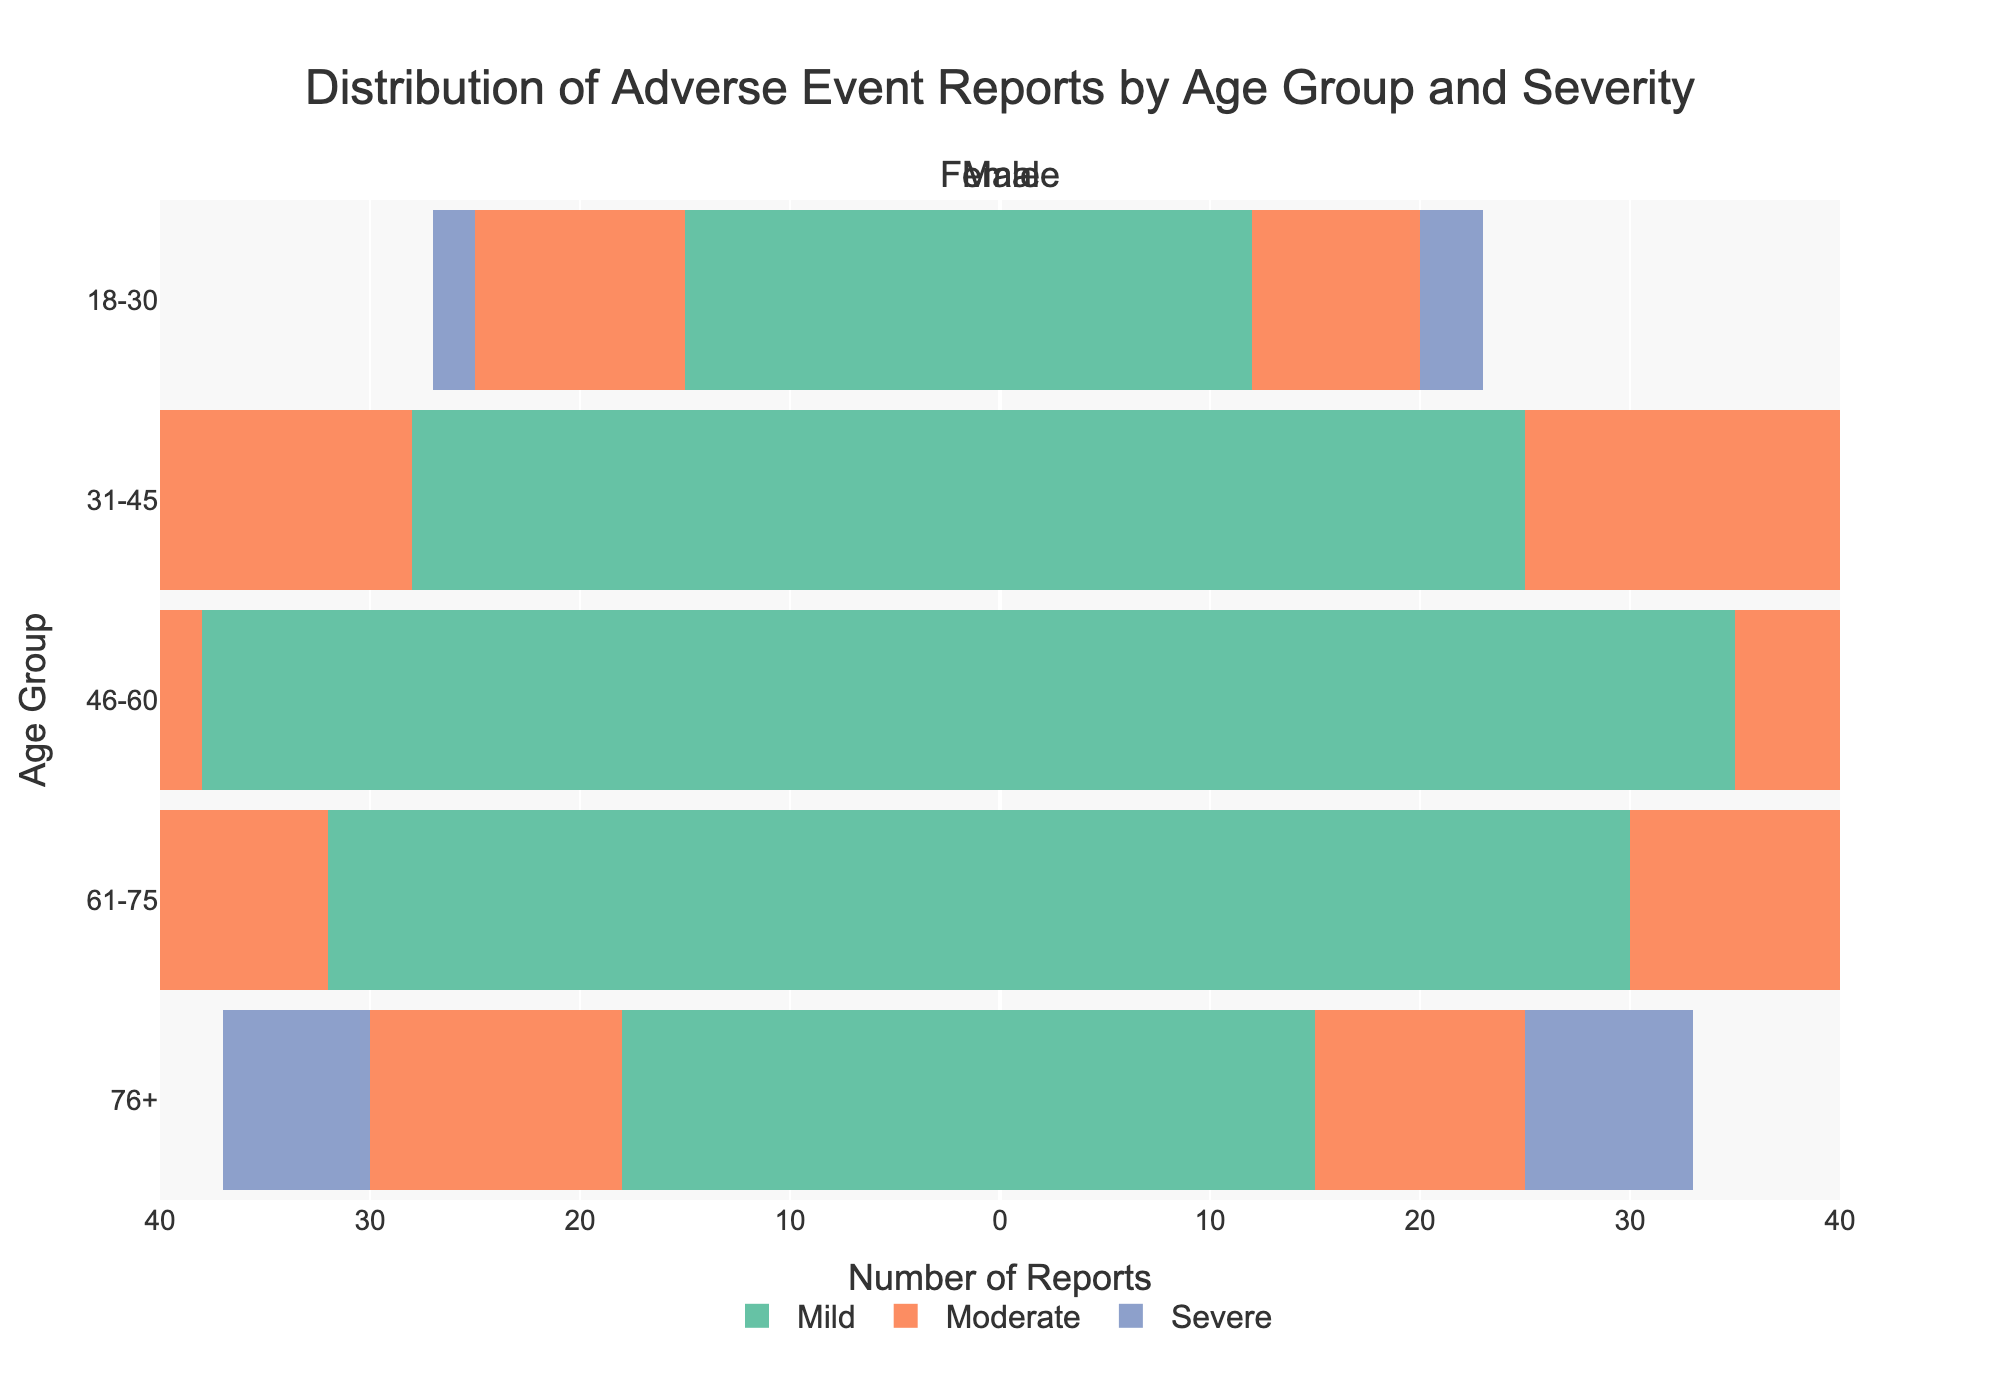Which age group has the highest number of mild adverse event reports in males? Look at the mild category for males and identify the age group with the longest bar. The age group 46-60 has a bar extending to 35, which is the highest.
Answer: 46-60 In the 31-45 age group, how many total severe adverse event reports were there? Add the severe adverse event reports for both males and females in the 31-45 age group. For males, there are 7 reports, and for females, there are 6 reports. Summing these gives 7 + 6 = 13.
Answer: 13 Which severity level has the most adverse event reports in females aged 76+? Look at the bars for females in the 76+ age group and identify which severity level's bar extends the furthest to the left. The mild severity has a bar extending to -18.
Answer: Mild Compare the number of moderate adverse event reports in males between the 46-60 age group and the 61-75 age group. Which age group has more reports? Locate the bars for moderate severity in males for the age groups 46-60 and 61-75. For 46-60, the bar extends to 22. For 61-75, it extends to 20, showing 46-60 has more reports.
Answer: 46-60 What is the total number of adverse event reports for both males and females in the 18-30 age group? Sum the adverse event reports for males and females in all severity levels for the 18-30 age group. (12+8+3) + (15+10+2) = 23 + 27 = 50.
Answer: 50 What proportion of severe adverse event reports occur in the 61-75 age group compared to the total severe adverse events across all age groups? Calculate the total severe events for all age groups first: (3+2) + (7+6) + (10+9) + (12+11) + (8+7) = 75.
Then, find the severe events in 61-75: 12 (males) + 11 (females) = 23.
Finally, compute the proportion: 23/75.
Answer: 23/75 Which gender has a higher number of mild adverse event reports in the 31-45 age group? Look at the mild category for the 31-45 age group and compare the lengths of the bars for males (25) and females (28). Females have a higher number.
Answer: Female What is the average number of moderate adverse event reports for the males in the 18-30 and 31-45 age groups? Add the moderate adverse event reports for males in the 18-30 (8) and 31-45 (18) age groups and divide by 2. (8+18)/2 = 26/2 = 13.
Answer: 13 Between the 46-60 and 61-75 age groups, which has the higher total number of adverse event reports for both genders combined? Sum the reports for both males and females in these age groups:
46-60: (35+22+10) + (38+25+9) = 139.
61-75: (30+20+12) + (32+22+11) = 127.
Hence, 46-60 has higher total reports.
Answer: 46-60 Which age group has the smallest number of adverse event reports for males under the severe severity? Look at the severe category for males and compare all age groups. The age group 18-30 has the smallest number with 3 reports.
Answer: 18-30 